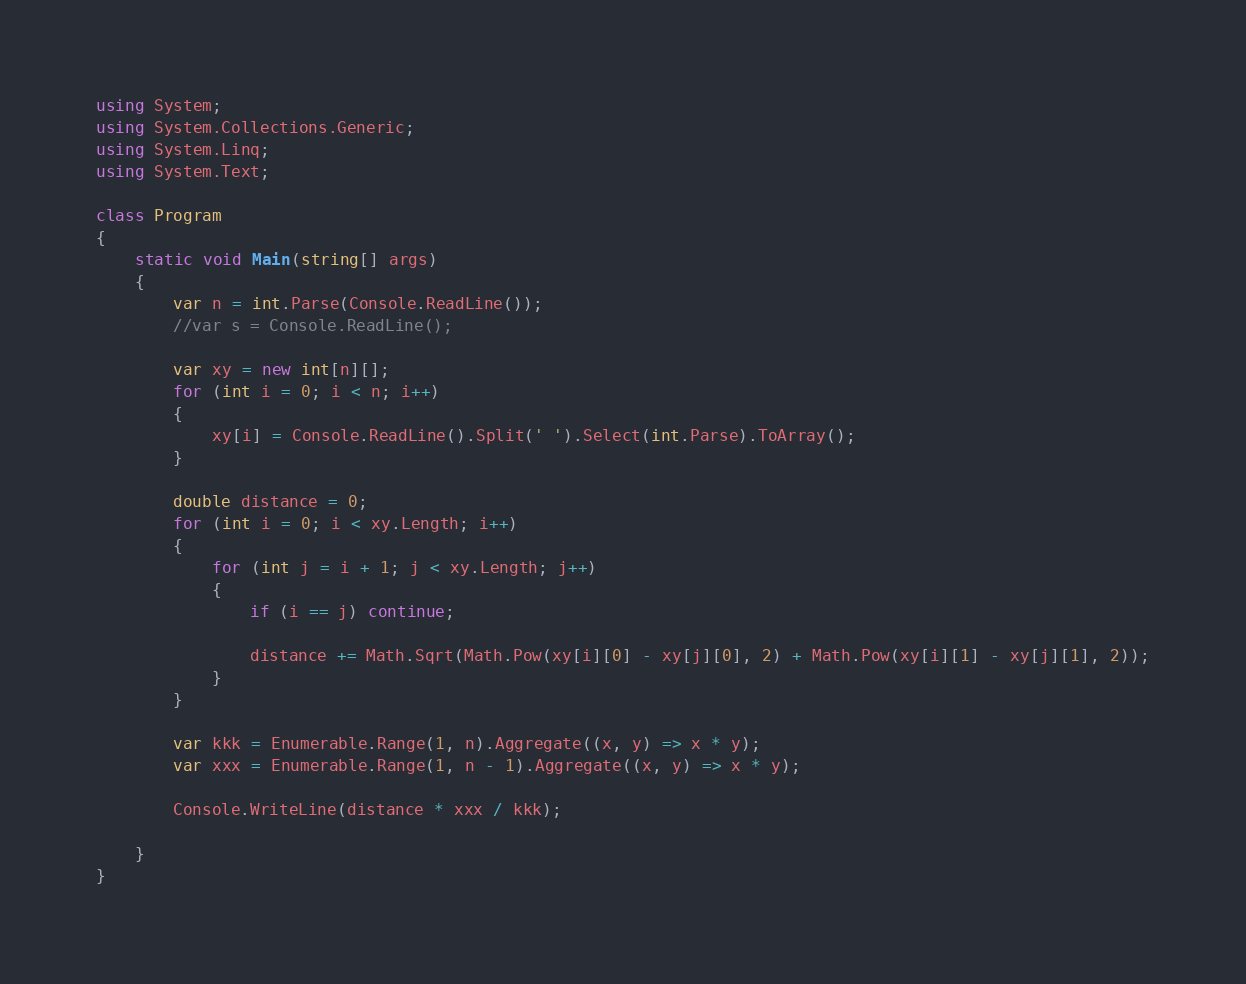<code> <loc_0><loc_0><loc_500><loc_500><_C#_>using System;
using System.Collections.Generic;
using System.Linq;
using System.Text;

class Program
{
    static void Main(string[] args)
    {
        var n = int.Parse(Console.ReadLine());
        //var s = Console.ReadLine();

        var xy = new int[n][];
        for (int i = 0; i < n; i++)
        {
            xy[i] = Console.ReadLine().Split(' ').Select(int.Parse).ToArray();
        }

        double distance = 0;
        for (int i = 0; i < xy.Length; i++)
        {
            for (int j = i + 1; j < xy.Length; j++)
            {
                if (i == j) continue;

                distance += Math.Sqrt(Math.Pow(xy[i][0] - xy[j][0], 2) + Math.Pow(xy[i][1] - xy[j][1], 2));
            }
        }

        var kkk = Enumerable.Range(1, n).Aggregate((x, y) => x * y);
        var xxx = Enumerable.Range(1, n - 1).Aggregate((x, y) => x * y);

        Console.WriteLine(distance * xxx / kkk);

    }
}</code> 